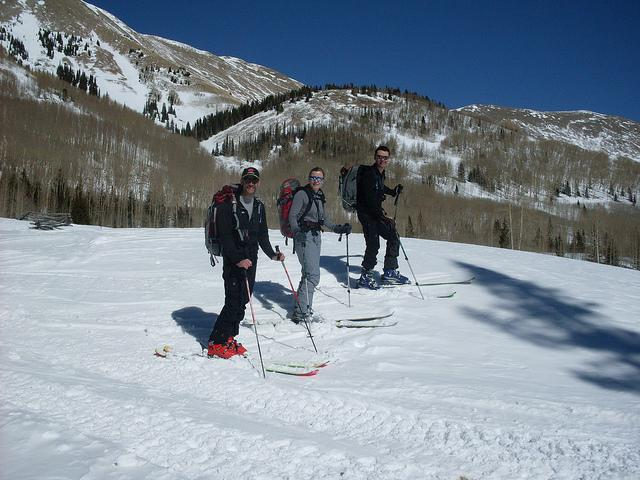Why are they off the path? Please explain your reasoning. posing. They are having their photo taken. 